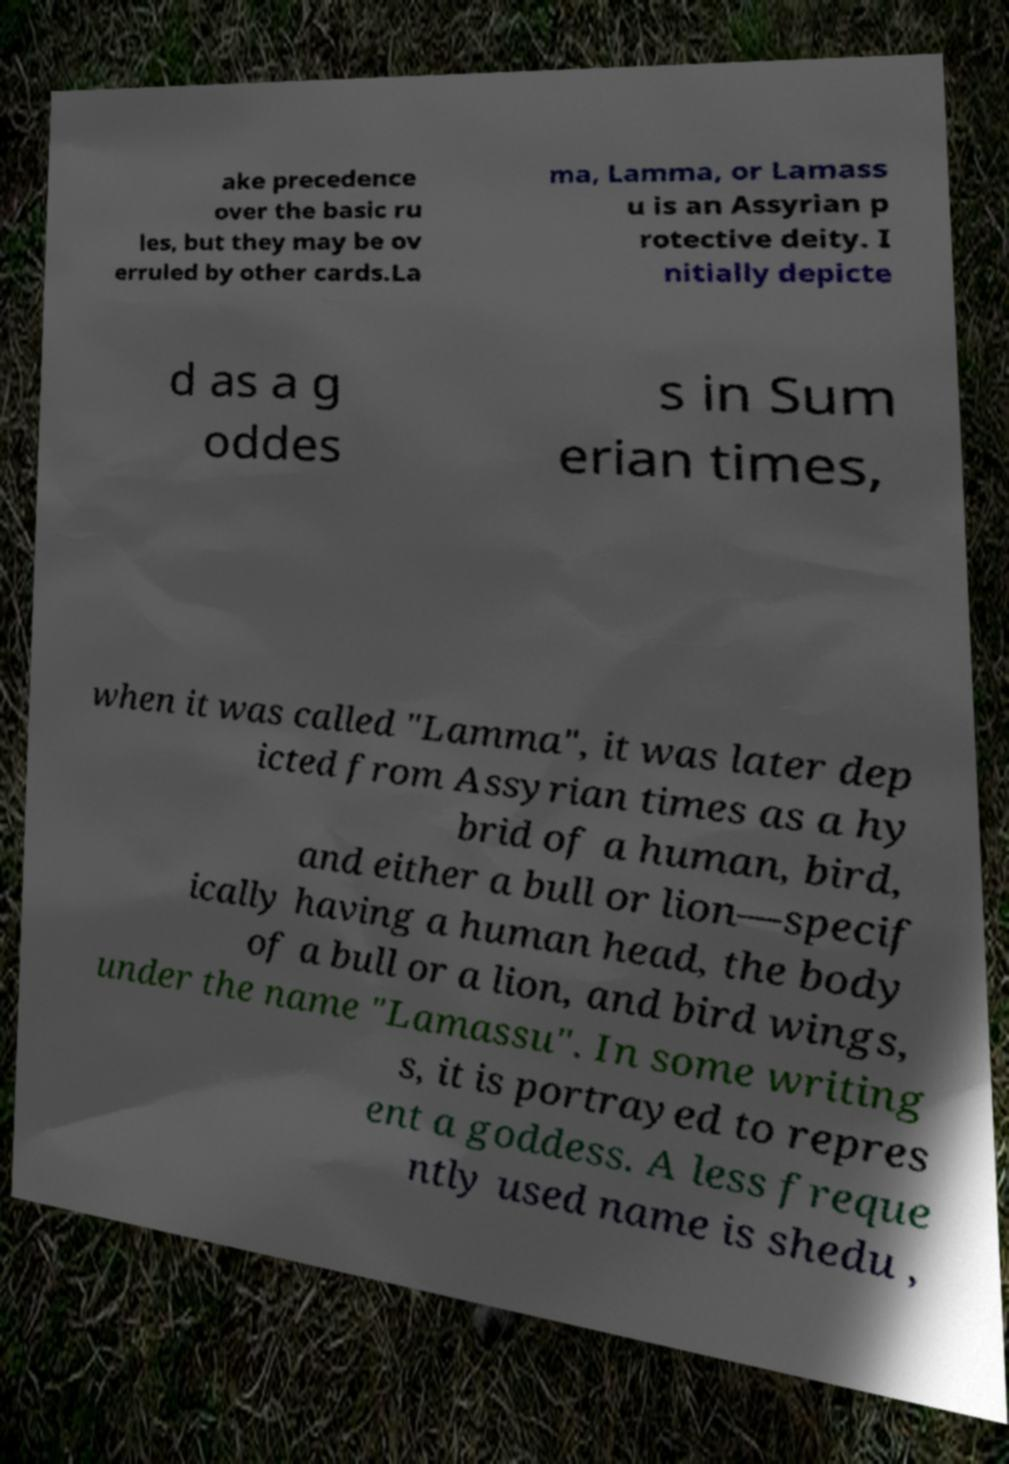There's text embedded in this image that I need extracted. Can you transcribe it verbatim? ake precedence over the basic ru les, but they may be ov erruled by other cards.La ma, Lamma, or Lamass u is an Assyrian p rotective deity. I nitially depicte d as a g oddes s in Sum erian times, when it was called "Lamma", it was later dep icted from Assyrian times as a hy brid of a human, bird, and either a bull or lion—specif ically having a human head, the body of a bull or a lion, and bird wings, under the name "Lamassu". In some writing s, it is portrayed to repres ent a goddess. A less freque ntly used name is shedu , 